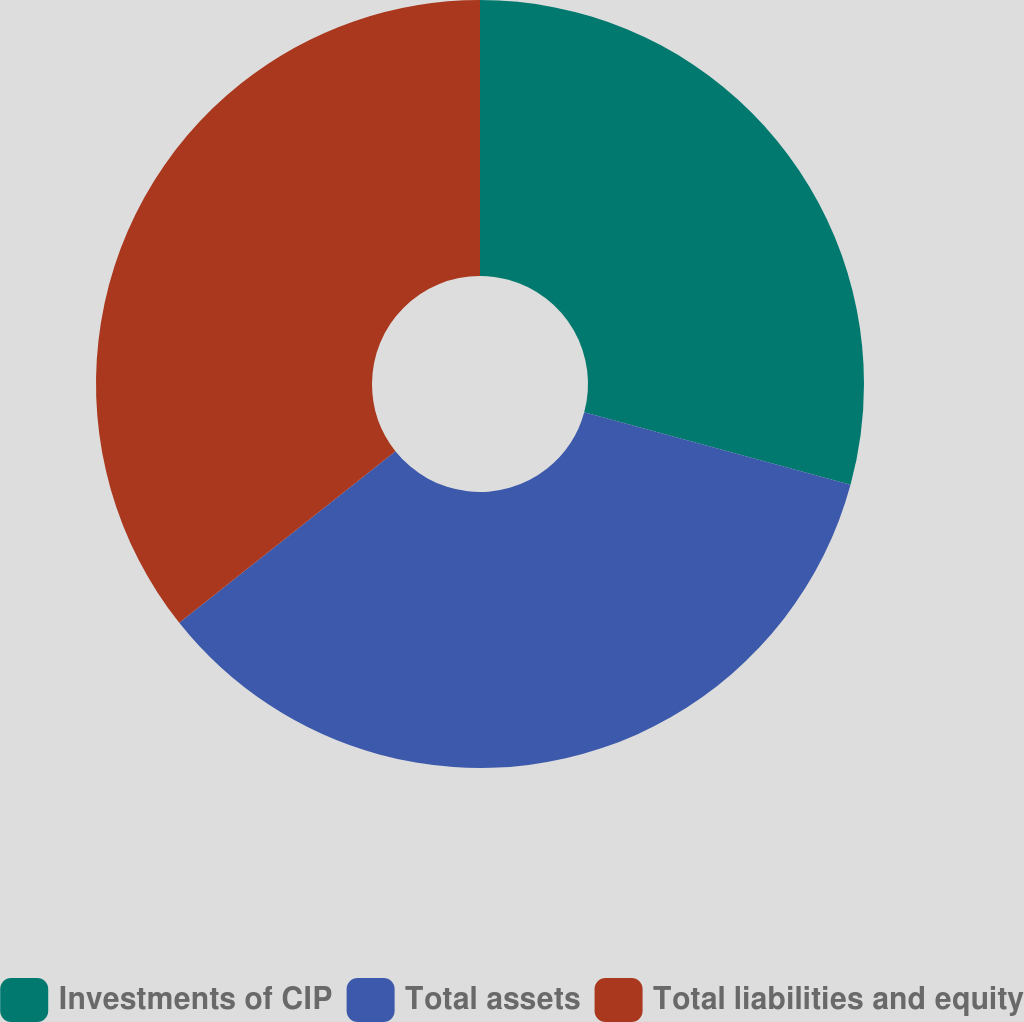Convert chart to OTSL. <chart><loc_0><loc_0><loc_500><loc_500><pie_chart><fcel>Investments of CIP<fcel>Total assets<fcel>Total liabilities and equity<nl><fcel>29.23%<fcel>35.09%<fcel>35.68%<nl></chart> 